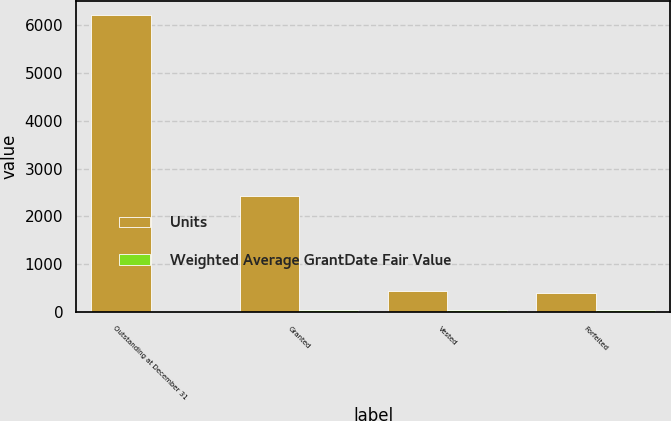Convert chart to OTSL. <chart><loc_0><loc_0><loc_500><loc_500><stacked_bar_chart><ecel><fcel>Outstanding at December 31<fcel>Granted<fcel>Vested<fcel>Forfeited<nl><fcel>Units<fcel>6207<fcel>2427<fcel>434<fcel>389<nl><fcel>Weighted Average GrantDate Fair Value<fcel>23.76<fcel>30.33<fcel>36.96<fcel>39.74<nl></chart> 